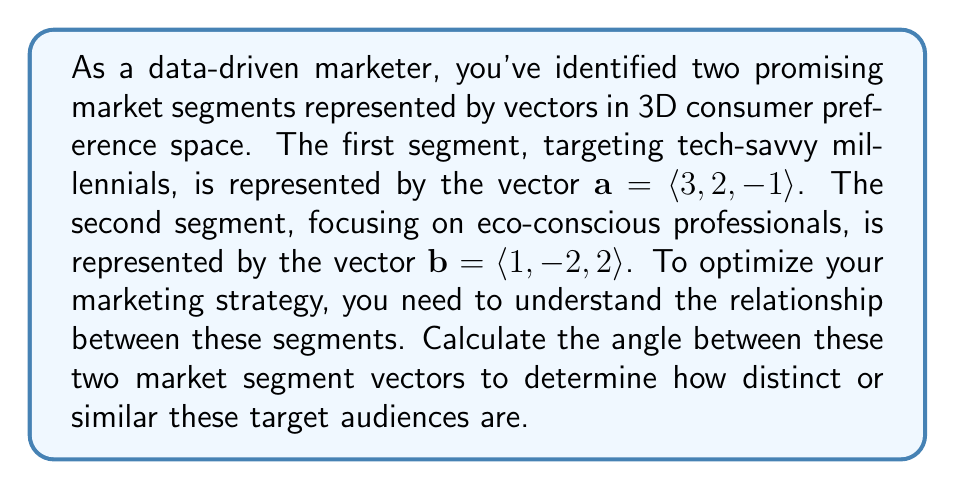Show me your answer to this math problem. To find the angle between two vectors in 3D space, we can use the dot product formula:

$$\cos \theta = \frac{\mathbf{a} \cdot \mathbf{b}}{|\mathbf{a}||\mathbf{b}|}$$

Where $\theta$ is the angle between vectors $\mathbf{a}$ and $\mathbf{b}$.

Let's solve this step-by-step:

1) First, calculate the dot product $\mathbf{a} \cdot \mathbf{b}$:
   $$\mathbf{a} \cdot \mathbf{b} = (3)(1) + (2)(-2) + (-1)(2) = 3 - 4 - 2 = -3$$

2) Calculate the magnitudes of vectors $\mathbf{a}$ and $\mathbf{b}$:
   $$|\mathbf{a}| = \sqrt{3^2 + 2^2 + (-1)^2} = \sqrt{9 + 4 + 1} = \sqrt{14}$$
   $$|\mathbf{b}| = \sqrt{1^2 + (-2)^2 + 2^2} = \sqrt{1 + 4 + 4} = 3$$

3) Now, substitute these values into the dot product formula:
   $$\cos \theta = \frac{-3}{(\sqrt{14})(3)}$$

4) Simplify:
   $$\cos \theta = -\frac{1}{\sqrt{14}}$$

5) To find $\theta$, take the inverse cosine (arccos) of both sides:
   $$\theta = \arccos(-\frac{1}{\sqrt{14}})$$

6) Using a calculator or computer, we can evaluate this:
   $$\theta \approx 1.6656 \text{ radians}$$

7) Convert to degrees:
   $$\theta \approx 1.6656 \times \frac{180}{\pi} \approx 95.44°$$
Answer: The angle between the two market segment vectors is approximately 95.44°. 